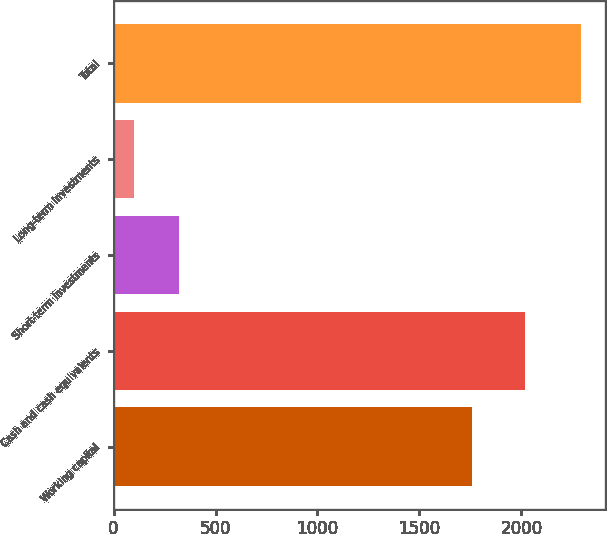Convert chart to OTSL. <chart><loc_0><loc_0><loc_500><loc_500><bar_chart><fcel>Working capital<fcel>Cash and cash equivalents<fcel>Short-term investments<fcel>Long-term investments<fcel>Total<nl><fcel>1759.6<fcel>2019.1<fcel>320.6<fcel>101.4<fcel>2293.4<nl></chart> 